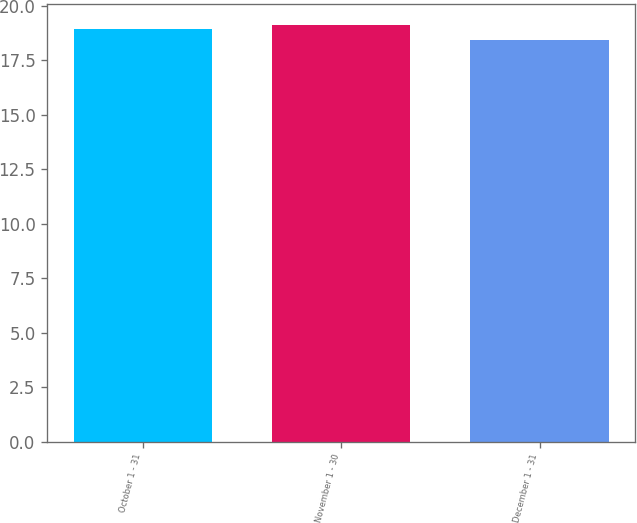Convert chart. <chart><loc_0><loc_0><loc_500><loc_500><bar_chart><fcel>October 1 - 31<fcel>November 1 - 30<fcel>December 1 - 31<nl><fcel>18.95<fcel>19.13<fcel>18.42<nl></chart> 